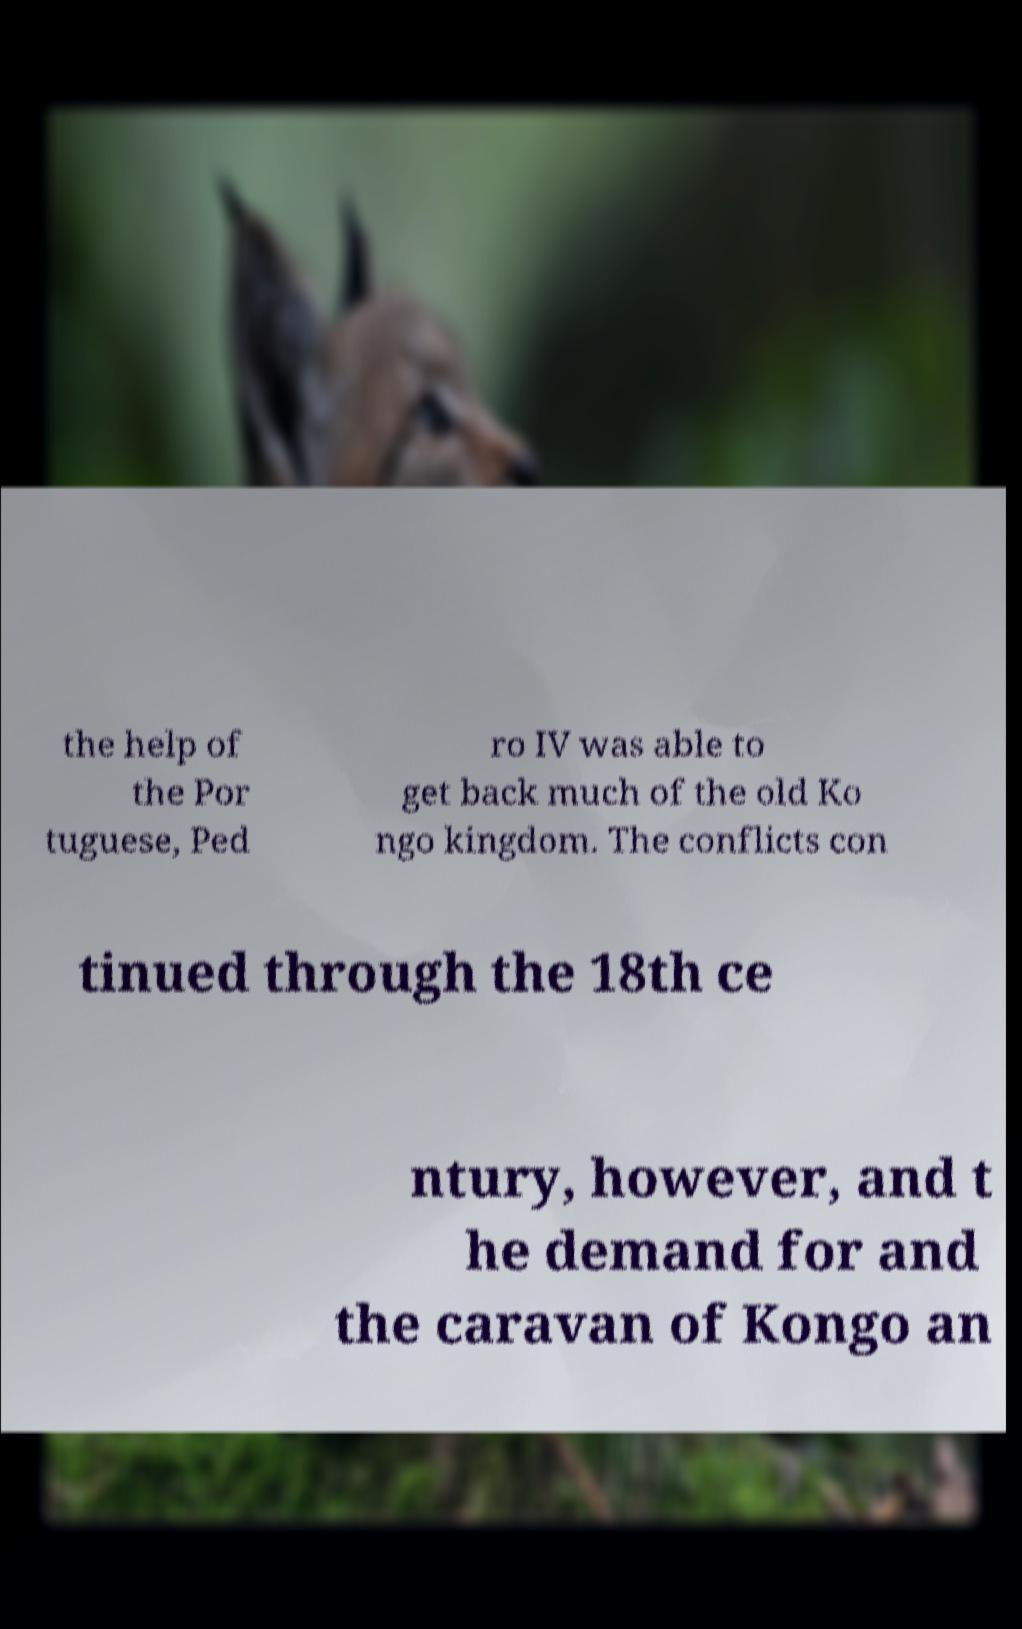Could you extract and type out the text from this image? the help of the Por tuguese, Ped ro IV was able to get back much of the old Ko ngo kingdom. The conflicts con tinued through the 18th ce ntury, however, and t he demand for and the caravan of Kongo an 